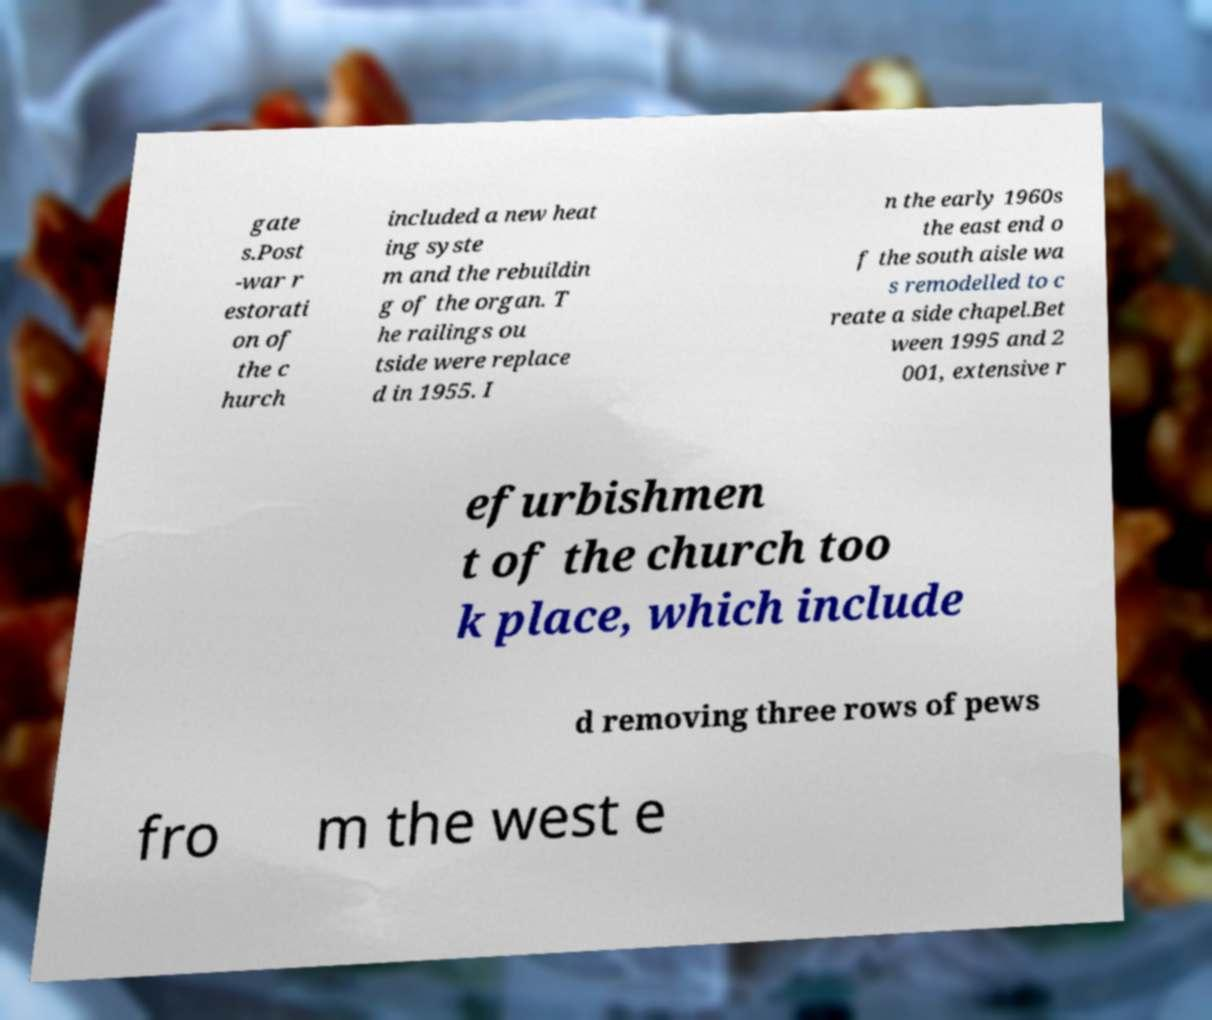Please read and relay the text visible in this image. What does it say? gate s.Post -war r estorati on of the c hurch included a new heat ing syste m and the rebuildin g of the organ. T he railings ou tside were replace d in 1955. I n the early 1960s the east end o f the south aisle wa s remodelled to c reate a side chapel.Bet ween 1995 and 2 001, extensive r efurbishmen t of the church too k place, which include d removing three rows of pews fro m the west e 